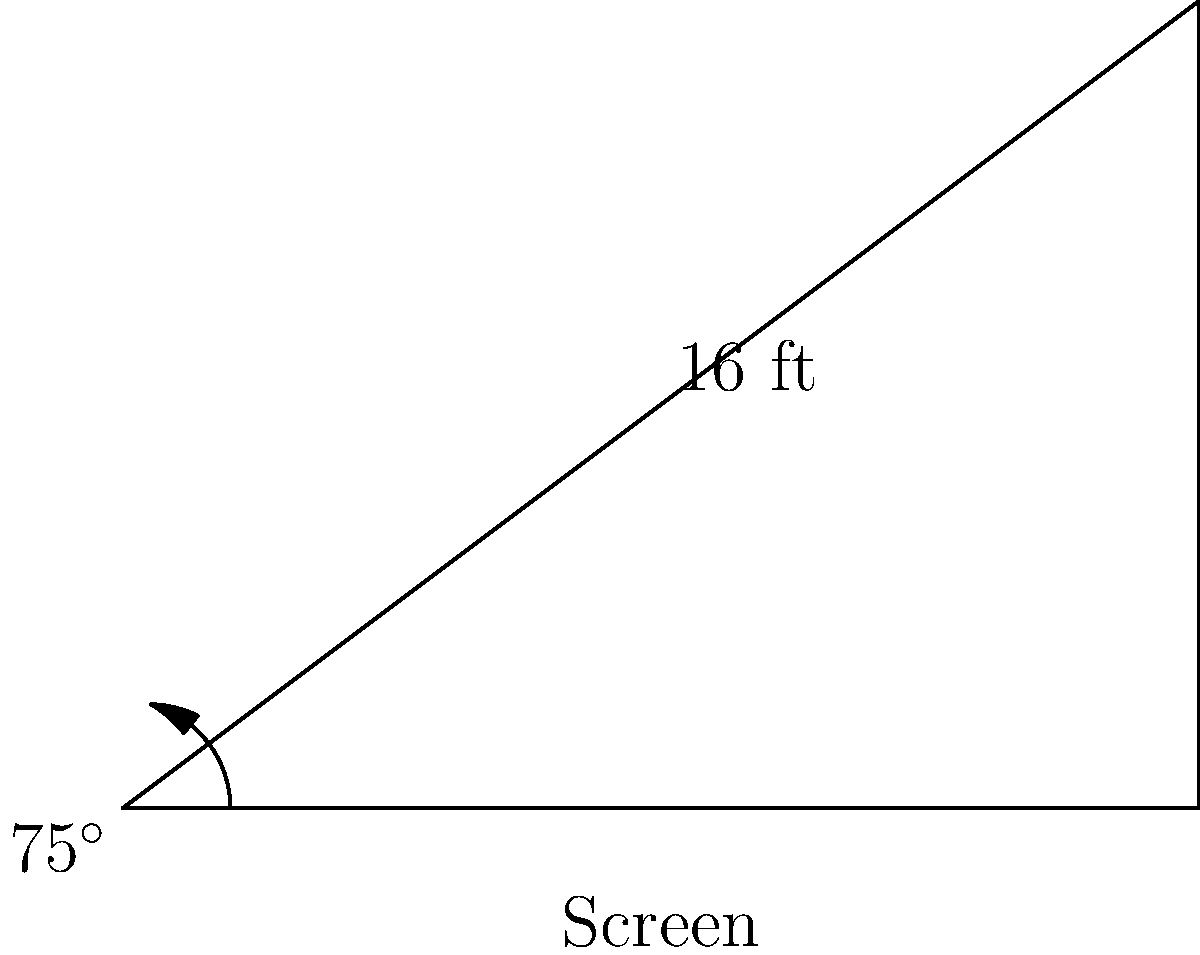At your local cinema showing the latest Bradley Cooper movie, you're curious about the screen dimensions. The screen's diagonal measures 16 feet, and the viewing angle from the bottom corner is 75°. What is the width of the screen to the nearest inch? Let's approach this step-by-step:

1) First, we can model this as a right triangle, where:
   - The hypotenuse is the diagonal (16 feet)
   - The angle between the base and hypotenuse is 75°
   - We need to find the base (width of the screen)

2) In a right triangle, we can use the cosine function:

   $\cos \theta = \frac{\text{adjacent}}{\text{hypotenuse}}$

3) In our case:
   $\cos 75° = \frac{\text{width}}{16}$

4) Rearranging the equation:
   $\text{width} = 16 \times \cos 75°$

5) Now let's calculate:
   $\text{width} = 16 \times \cos 75°$
   $\text{width} = 16 \times 0.2588...$ 
   $\text{width} = 4.1408...$ feet

6) Convert to inches:
   $4.1408... \times 12 = 49.6896...$ inches

7) Rounding to the nearest inch:
   $49.6896... \approx 50$ inches

Therefore, the width of the screen is approximately 50 inches.
Answer: 50 inches 